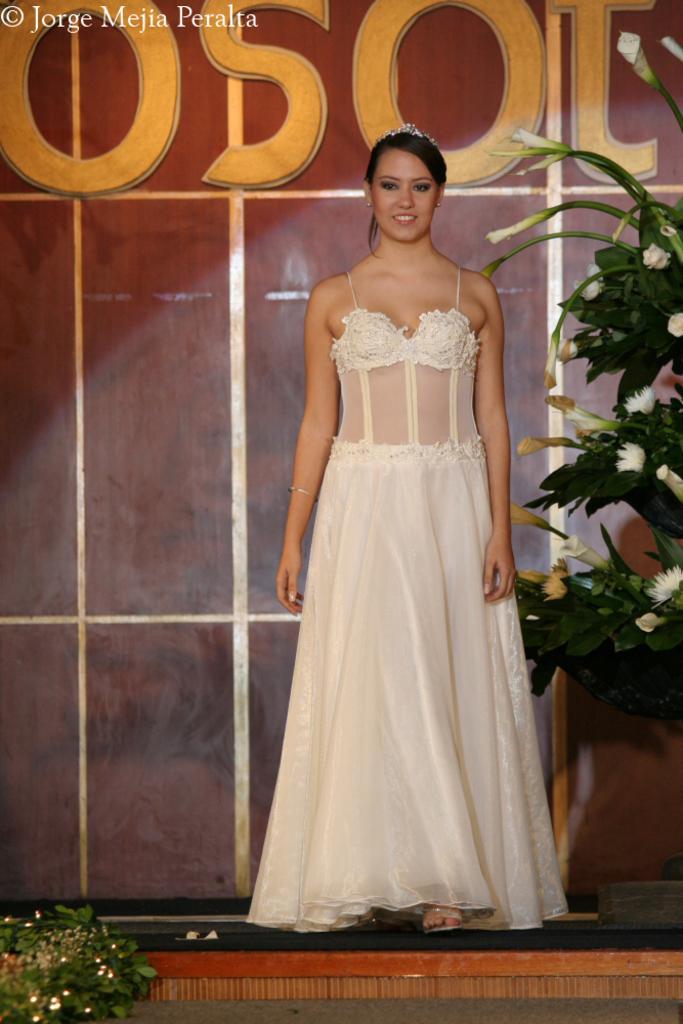Could you give a brief overview of what you see in this image? In this image we can see a woman standing on the floor. We can also see some plants with flowers. On the backside we can see a wall and some text on it. 